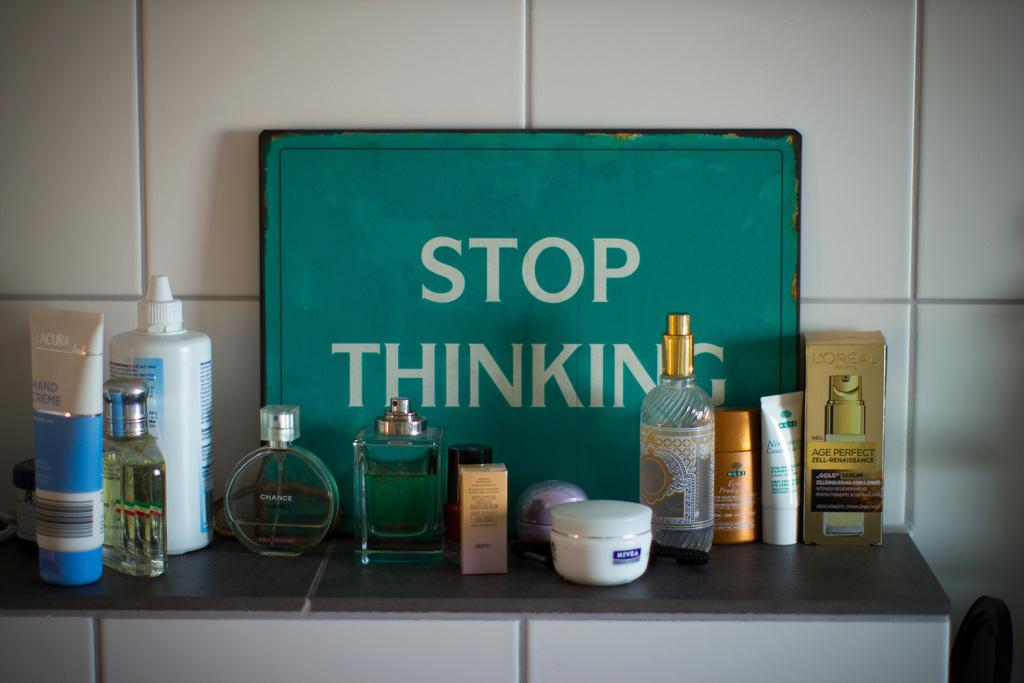<image>
Write a terse but informative summary of the picture. A sign in a bathroom recommends that people stop thinking. 